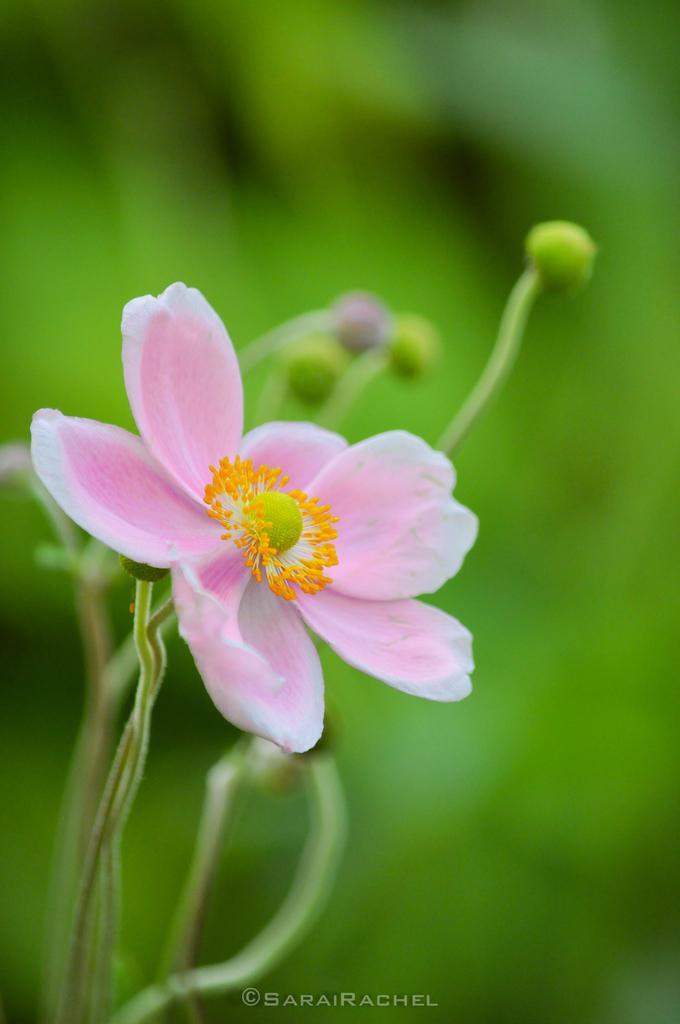Could you give a brief overview of what you see in this image? In this image I can see a flower which is pink, yellow and green in color to a plant which is green in color. I can see the green colored blurry background. 